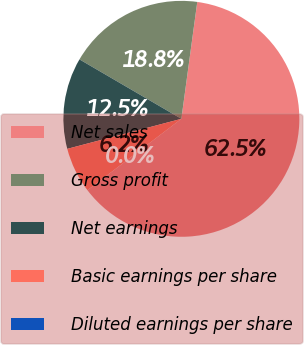Convert chart. <chart><loc_0><loc_0><loc_500><loc_500><pie_chart><fcel>Net sales<fcel>Gross profit<fcel>Net earnings<fcel>Basic earnings per share<fcel>Diluted earnings per share<nl><fcel>62.5%<fcel>18.75%<fcel>12.5%<fcel>6.25%<fcel>0.0%<nl></chart> 